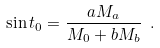<formula> <loc_0><loc_0><loc_500><loc_500>\sin t _ { 0 } = \frac { a M _ { a } } { M _ { 0 } + b M _ { b } } \ .</formula> 